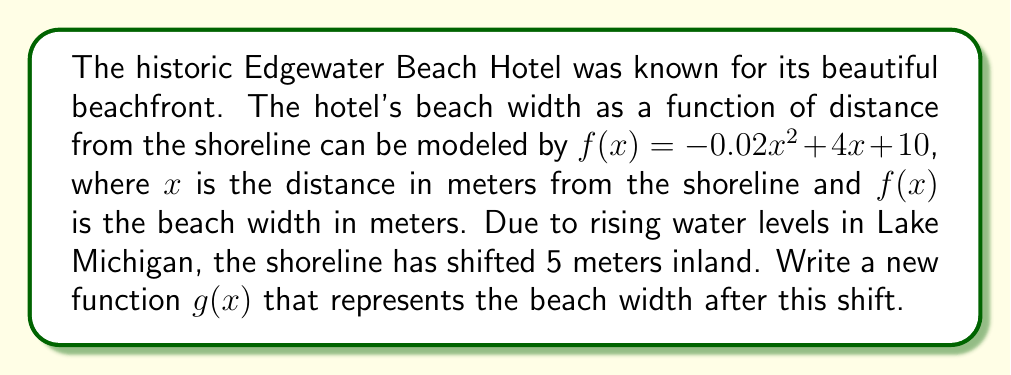What is the answer to this math problem? To solve this problem, we need to translate the function horizontally to represent the shift in the shoreline. Since the shoreline has moved 5 meters inland, we need to shift the function 5 units to the right.

The general form for a horizontal shift of a function is:
$g(x) = f(x - h)$, where $h$ is the number of units to shift right (or left if negative).

In this case, we're shifting 5 units to the right, so:
$g(x) = f(x - 5)$

Now, let's substitute the original function $f(x)$ into this equation:

$g(x) = -0.02(x - 5)^2 + 4(x - 5) + 10$

Expanding the squared term:
$g(x) = -0.02(x^2 - 10x + 25) + 4x - 20 + 10$

Simplifying:
$g(x) = -0.02x^2 + 0.4x - 0.5 + 4x - 20 + 10$
$g(x) = -0.02x^2 + 4.4x - 10.5$

This is the new function representing the beach width after the shoreline shift.
Answer: $g(x) = -0.02x^2 + 4.4x - 10.5$ 